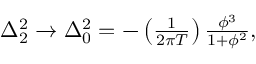Convert formula to latex. <formula><loc_0><loc_0><loc_500><loc_500>\begin{array} { r } { \Delta _ { 2 } ^ { 2 } \rightarrow \Delta _ { 0 } ^ { 2 } = - \left ( \frac { 1 } { 2 \pi T } \right ) \frac { \phi ^ { 3 } } { 1 + \phi ^ { 2 } } , } \end{array}</formula> 